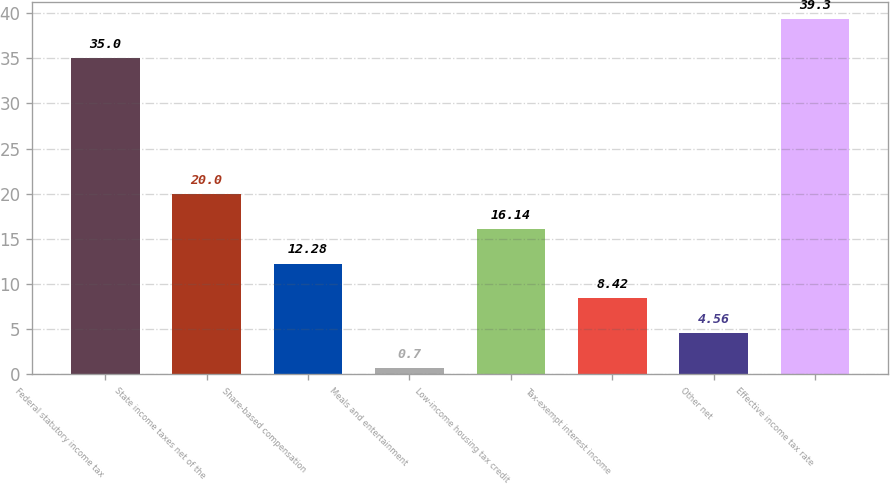Convert chart. <chart><loc_0><loc_0><loc_500><loc_500><bar_chart><fcel>Federal statutory income tax<fcel>State income taxes net of the<fcel>Share-based compensation<fcel>Meals and entertainment<fcel>Low-income housing tax credit<fcel>Tax-exempt interest income<fcel>Other net<fcel>Effective income tax rate<nl><fcel>35<fcel>20<fcel>12.28<fcel>0.7<fcel>16.14<fcel>8.42<fcel>4.56<fcel>39.3<nl></chart> 